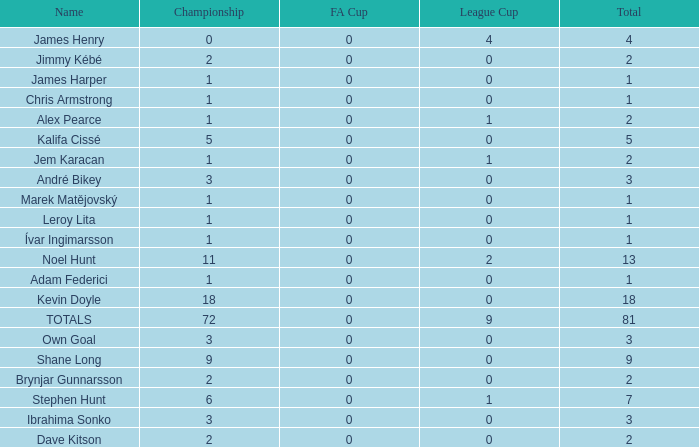What is the championship of Jem Karacan that has a total of 2 and a league cup more than 0? 1.0. 